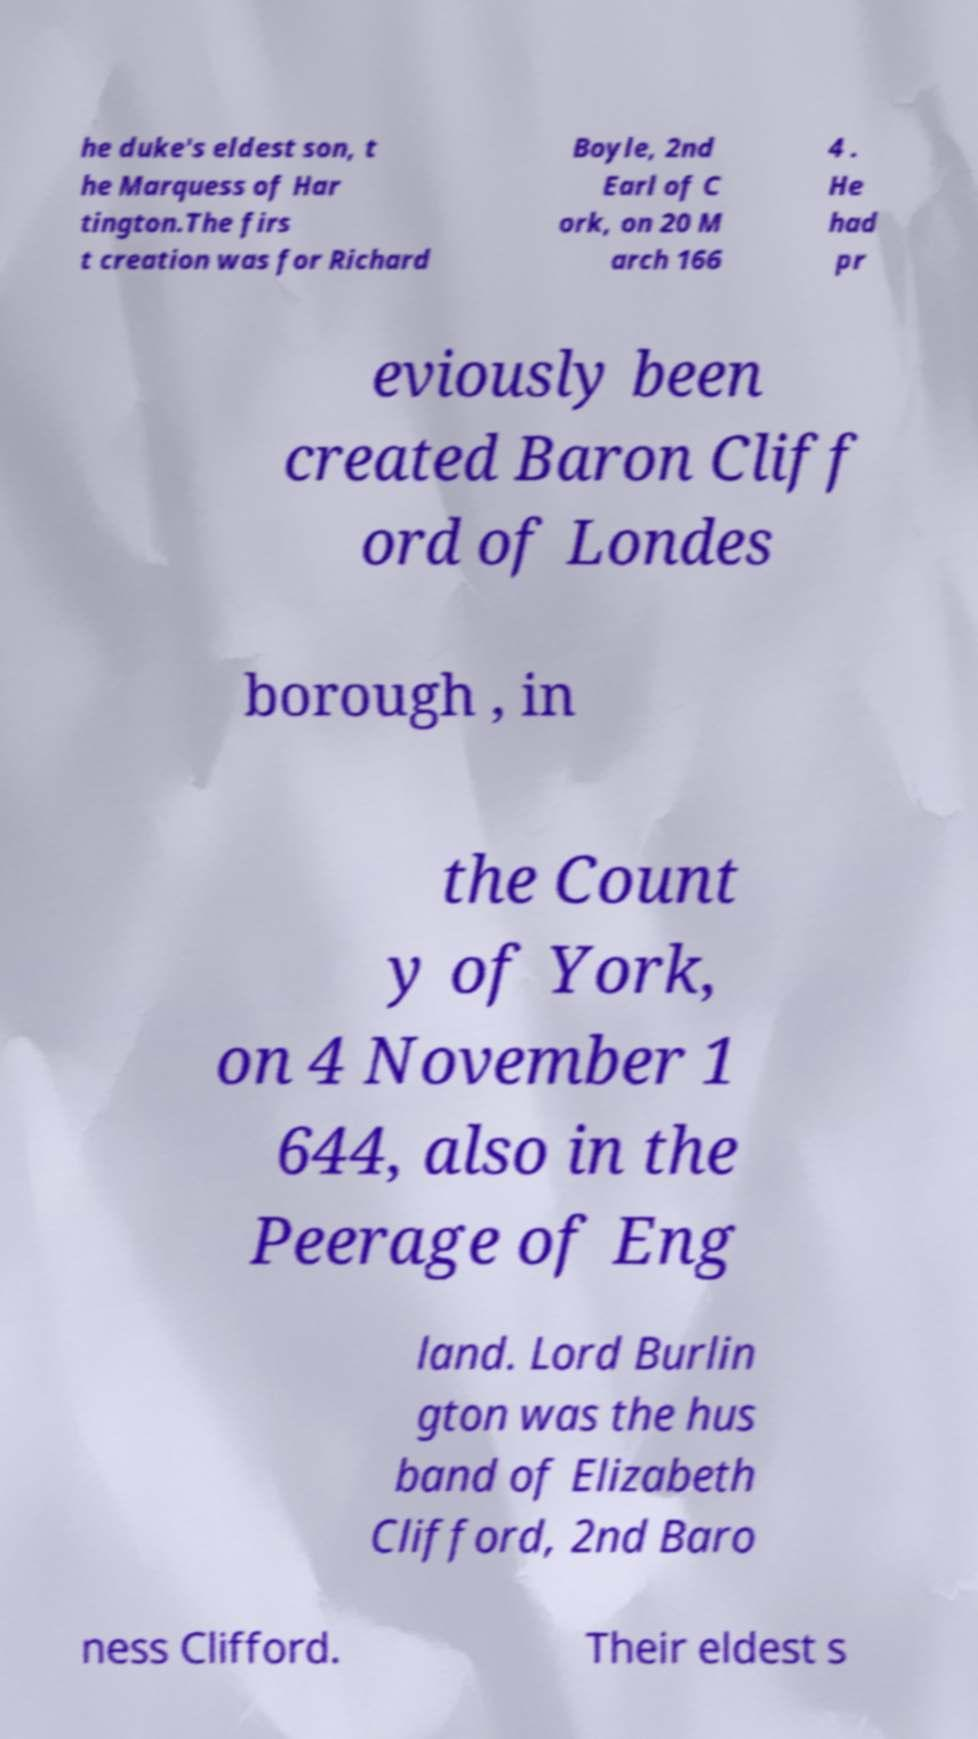For documentation purposes, I need the text within this image transcribed. Could you provide that? he duke's eldest son, t he Marquess of Har tington.The firs t creation was for Richard Boyle, 2nd Earl of C ork, on 20 M arch 166 4 . He had pr eviously been created Baron Cliff ord of Londes borough , in the Count y of York, on 4 November 1 644, also in the Peerage of Eng land. Lord Burlin gton was the hus band of Elizabeth Clifford, 2nd Baro ness Clifford. Their eldest s 